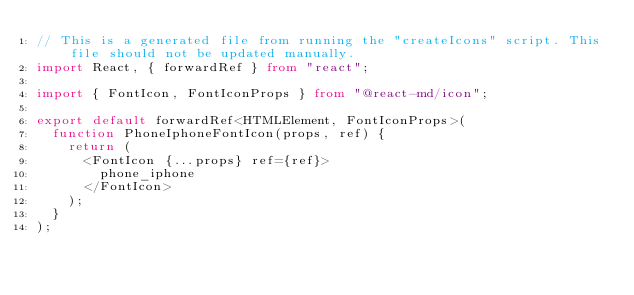Convert code to text. <code><loc_0><loc_0><loc_500><loc_500><_TypeScript_>// This is a generated file from running the "createIcons" script. This file should not be updated manually.
import React, { forwardRef } from "react";

import { FontIcon, FontIconProps } from "@react-md/icon";

export default forwardRef<HTMLElement, FontIconProps>(
  function PhoneIphoneFontIcon(props, ref) {
    return (
      <FontIcon {...props} ref={ref}>
        phone_iphone
      </FontIcon>
    );
  }
);
</code> 